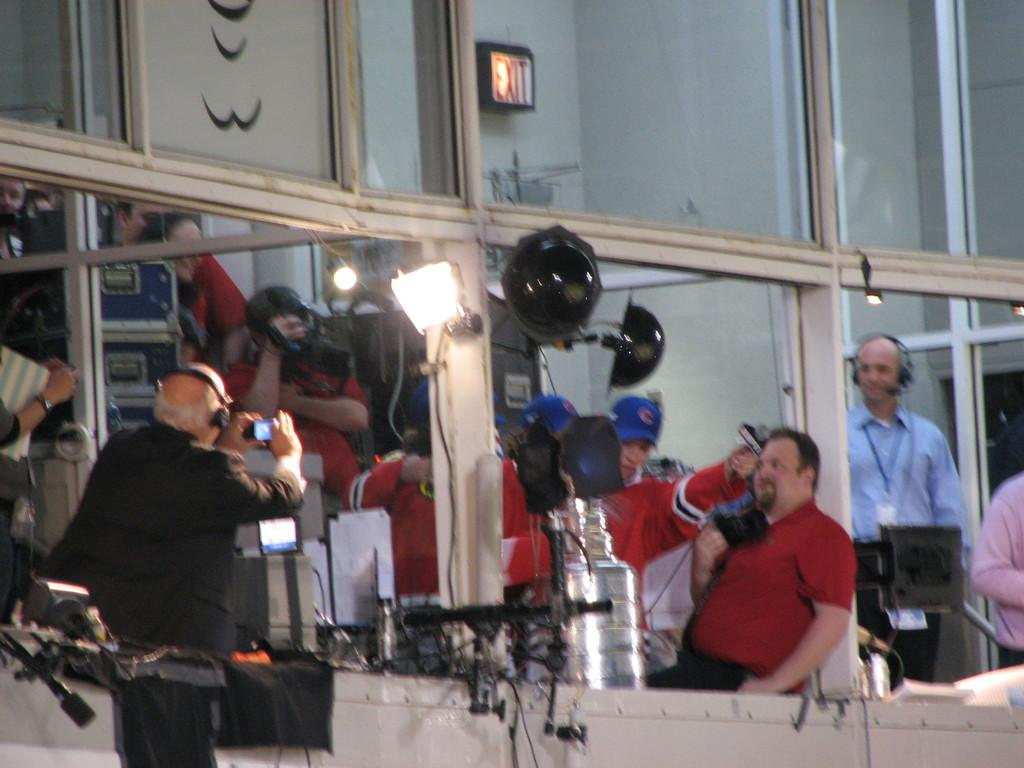Who is present in the image? There are people in the image. Where are the people located? The people are in a gallery. What can be seen in the gallery besides the people? There are lights, a camera, and electrical equipment in the gallery. What type of turkey can be seen in the gallery in the image? There is no turkey present in the gallery or the image. Can you describe the harbor that is visible in the image? There is no harbor visible in the image; it is set in a gallery. 